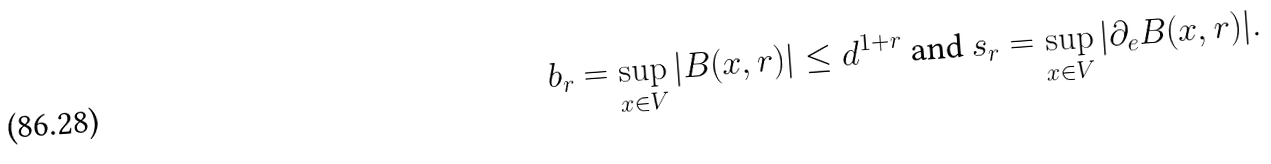Convert formula to latex. <formula><loc_0><loc_0><loc_500><loc_500>b _ { r } = \sup _ { x \in V } | B ( x , r ) | \leq d ^ { 1 + r } \text { and } s _ { r } = \sup _ { x \in V } | \partial _ { e } B ( x , r ) | .</formula> 